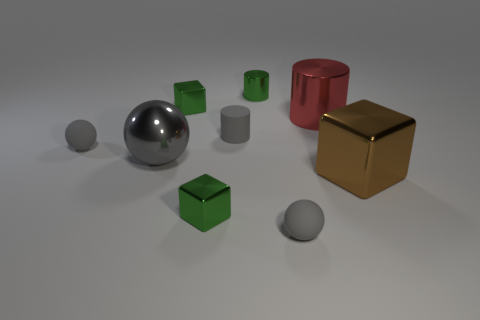Subtract all gray balls. How many were subtracted if there are1gray balls left? 2 Add 1 small green metal cubes. How many objects exist? 10 Add 6 gray metal objects. How many gray metal objects are left? 7 Add 3 tiny gray things. How many tiny gray things exist? 6 Subtract 0 gray cubes. How many objects are left? 9 Subtract all blocks. How many objects are left? 6 Subtract all gray balls. Subtract all large brown metal objects. How many objects are left? 5 